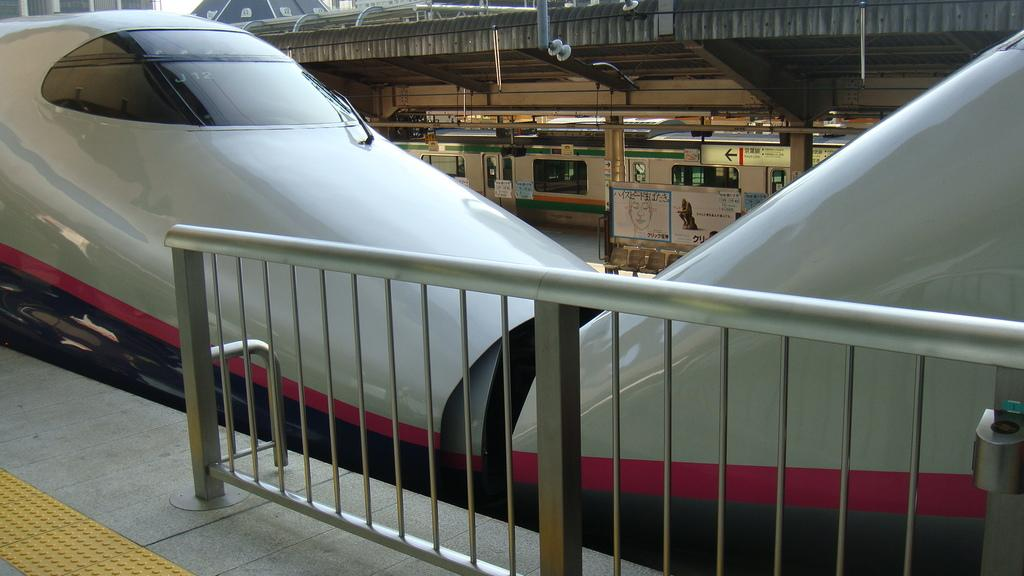What type of vehicles can be seen in the image? There are trains in the image. What type of pets are visible in the image? There are no pets visible in the image; it features trains. What time is displayed on the clock in the image? There is no clock present in the image. 